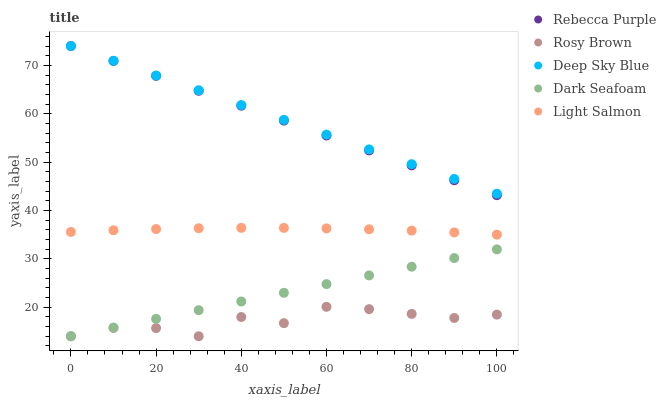Does Rosy Brown have the minimum area under the curve?
Answer yes or no. Yes. Does Deep Sky Blue have the maximum area under the curve?
Answer yes or no. Yes. Does Rebecca Purple have the minimum area under the curve?
Answer yes or no. No. Does Rebecca Purple have the maximum area under the curve?
Answer yes or no. No. Is Deep Sky Blue the smoothest?
Answer yes or no. Yes. Is Rosy Brown the roughest?
Answer yes or no. Yes. Is Rebecca Purple the smoothest?
Answer yes or no. No. Is Rebecca Purple the roughest?
Answer yes or no. No. Does Dark Seafoam have the lowest value?
Answer yes or no. Yes. Does Rebecca Purple have the lowest value?
Answer yes or no. No. Does Deep Sky Blue have the highest value?
Answer yes or no. Yes. Does Rosy Brown have the highest value?
Answer yes or no. No. Is Dark Seafoam less than Deep Sky Blue?
Answer yes or no. Yes. Is Light Salmon greater than Rosy Brown?
Answer yes or no. Yes. Does Rosy Brown intersect Dark Seafoam?
Answer yes or no. Yes. Is Rosy Brown less than Dark Seafoam?
Answer yes or no. No. Is Rosy Brown greater than Dark Seafoam?
Answer yes or no. No. Does Dark Seafoam intersect Deep Sky Blue?
Answer yes or no. No. 